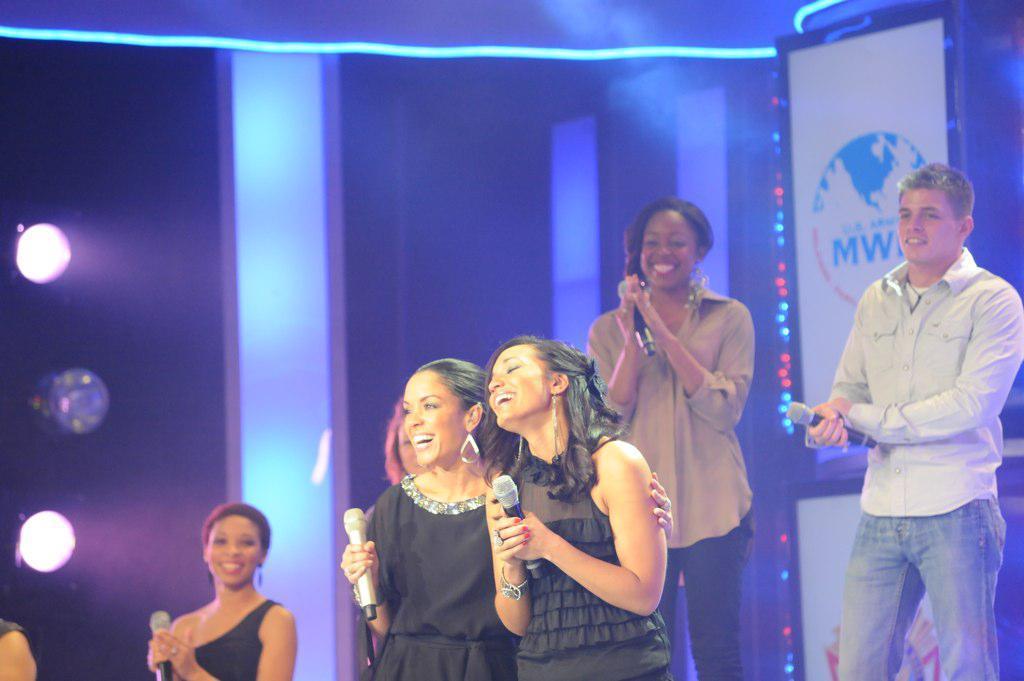Could you give a brief overview of what you see in this image? In this image we can see there are people standing and holding a microphone. At the back we can see there are photo frames with logo and text and there are lights attached to the wall. 